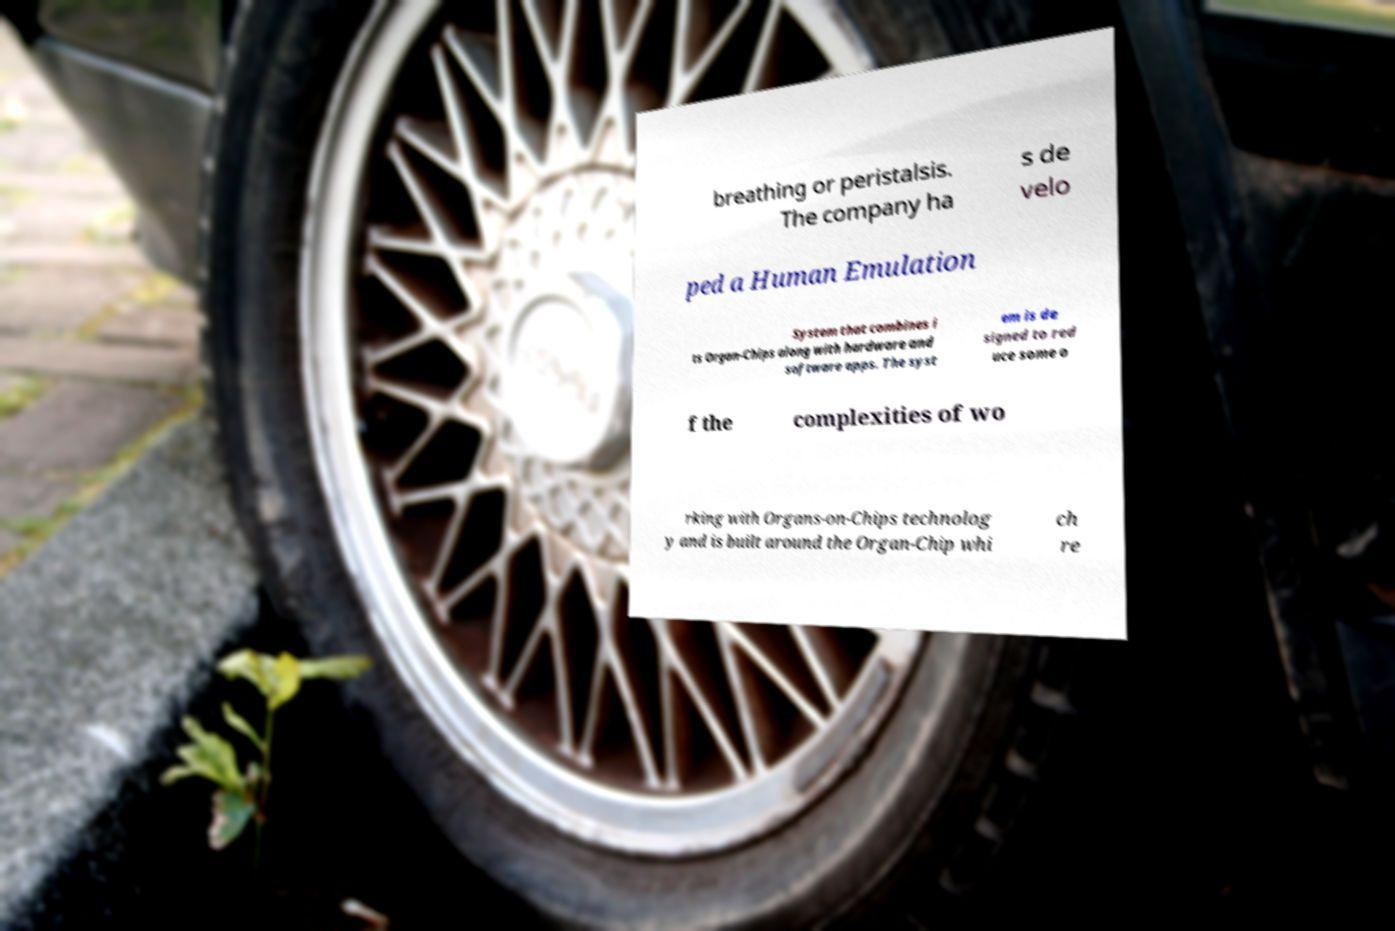Could you extract and type out the text from this image? breathing or peristalsis. The company ha s de velo ped a Human Emulation System that combines i ts Organ-Chips along with hardware and software apps. The syst em is de signed to red uce some o f the complexities of wo rking with Organs-on-Chips technolog y and is built around the Organ-Chip whi ch re 